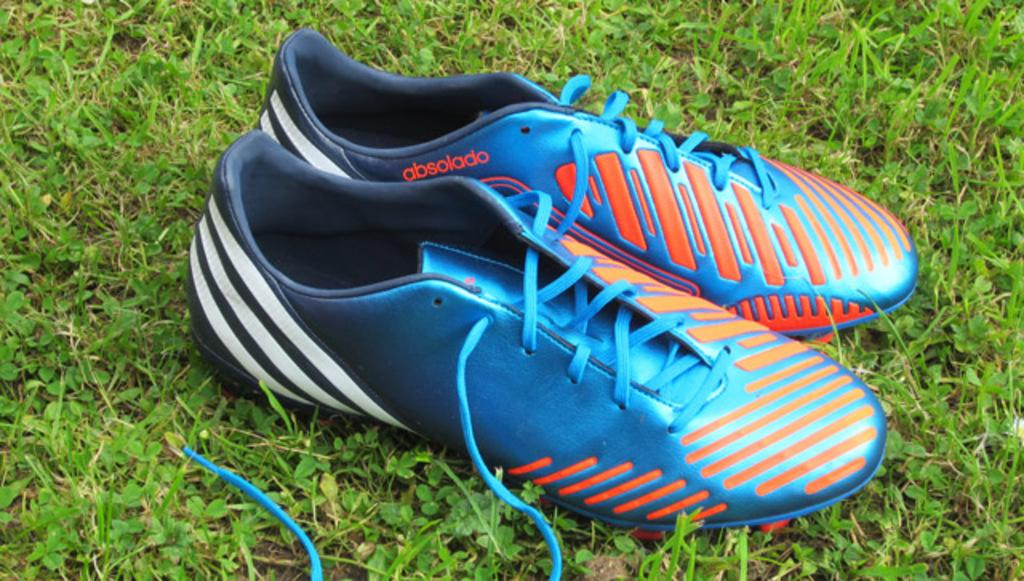What objects are present in the image? There are shoes in the image. Where are the shoes located? The shoes are placed on the grass. What type of pizzas are being served on the table in the image? There is no table or pizzas present in the image; it only features shoes placed on the grass. 